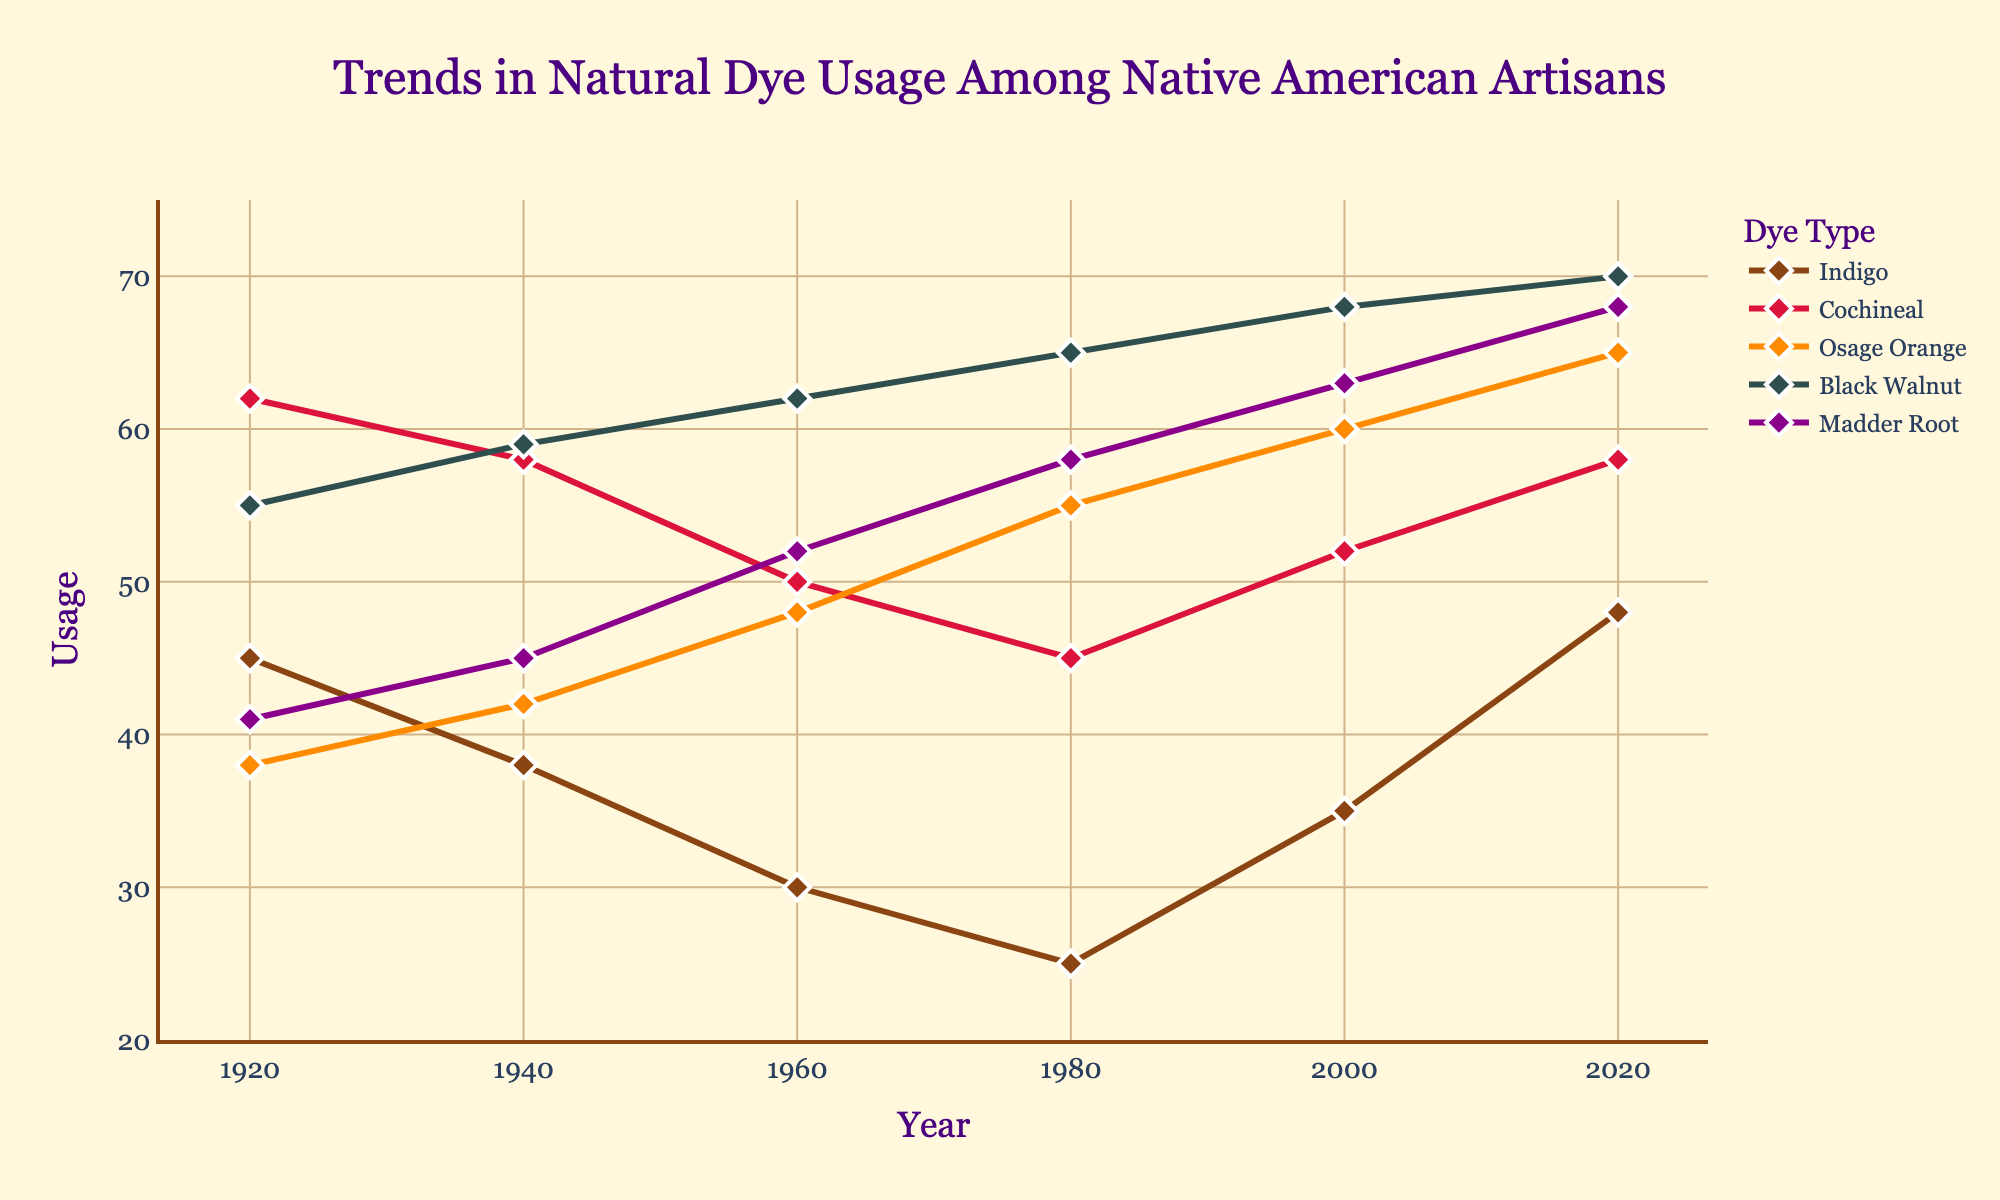Which dye showed the lowest usage in 1980? In 1980, check each line marker on the y-axis at the year 1980 to find the lowest value. Indigo shows the lowest usage.
Answer: Indigo How did the usage of Indigo and Madder Root change from 1920 to 2020? For both dyes, identify their values in 1920 and 2020. Indigo increased from 45 to 48, and Madder Root increased from 41 to 68. The increase for Indigo is 3 and for Madder Root is 27.
Answer: Indigo increased by 3, Madder Root increased by 27 Which dye had the highest increase in usage from 1960 to 2000? Identify the values for each dye in 1960 and 2000 and calculate the differences: Indigo (30 to 35 = 5), Cochineal (50 to 52 = 2), Osage Orange (48 to 60 = 12), Black Walnut (62 to 68 = 6), Madder Root (52 to 63 = 11). Osage Orange shows the highest increase.
Answer: Osage Orange What is the average usage of Black Walnut across all years? Sum the usage values for Black Walnut (55 + 59 + 62 + 65 + 68 + 70) = 379, and divide by the number of data points (6). The average usage is 379/6.
Answer: 63.17 Which dye had the least variation in usage over the century? Calculate the range (maximum - minimum) for each dye: Indigo (48 - 25 = 23), Cochineal (58 - 45 = 13), Osage Orange (65 - 38 = 27), Black Walnut (70 - 55 = 15), Madder Root (68 - 41 = 27). Cochineal shows the least variation.
Answer: Cochineal Which dye had a higher usage in 1940, Osage Orange or Cochineal? Look at the 1940 values for Osage Orange (42) and Cochineal (58). Cochineal usage is higher.
Answer: Cochineal How did the usage of Black Walnut change from 1920 to 1980? Identify the values for Black Walnut in 1920 (55) and 1980 (65). Calculate the change: 65 - 55 = 10.
Answer: Increased by 10 What is the overall trend for the usage of Madder Root between 1920 and 2020? Compare the values of Madder Root from 1920 (41) to 2020 (68). It increased overall, with values steadily rising.
Answer: Increased How many dyes showed higher usage than Indigo in 2020? Identify the usage values for all dyes in 2020. Compare with Indigo (48): Cochineal (58), Osage Orange (65), Black Walnut (70), Madder Root (68). Four dyes have higher usage than Indigo.
Answer: Four Was there any decade when Osage Orange usage dropped? Analyze the graph to see the trend of Osage Orange across decades. From 1920 to 2020, Osage Orange usage never decreases across any data points; it continuously increases.
Answer: No 